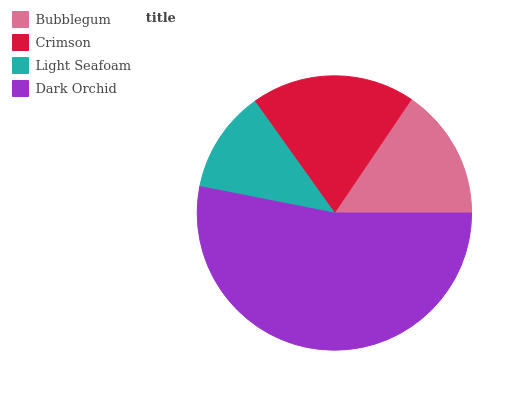Is Light Seafoam the minimum?
Answer yes or no. Yes. Is Dark Orchid the maximum?
Answer yes or no. Yes. Is Crimson the minimum?
Answer yes or no. No. Is Crimson the maximum?
Answer yes or no. No. Is Crimson greater than Bubblegum?
Answer yes or no. Yes. Is Bubblegum less than Crimson?
Answer yes or no. Yes. Is Bubblegum greater than Crimson?
Answer yes or no. No. Is Crimson less than Bubblegum?
Answer yes or no. No. Is Crimson the high median?
Answer yes or no. Yes. Is Bubblegum the low median?
Answer yes or no. Yes. Is Light Seafoam the high median?
Answer yes or no. No. Is Dark Orchid the low median?
Answer yes or no. No. 